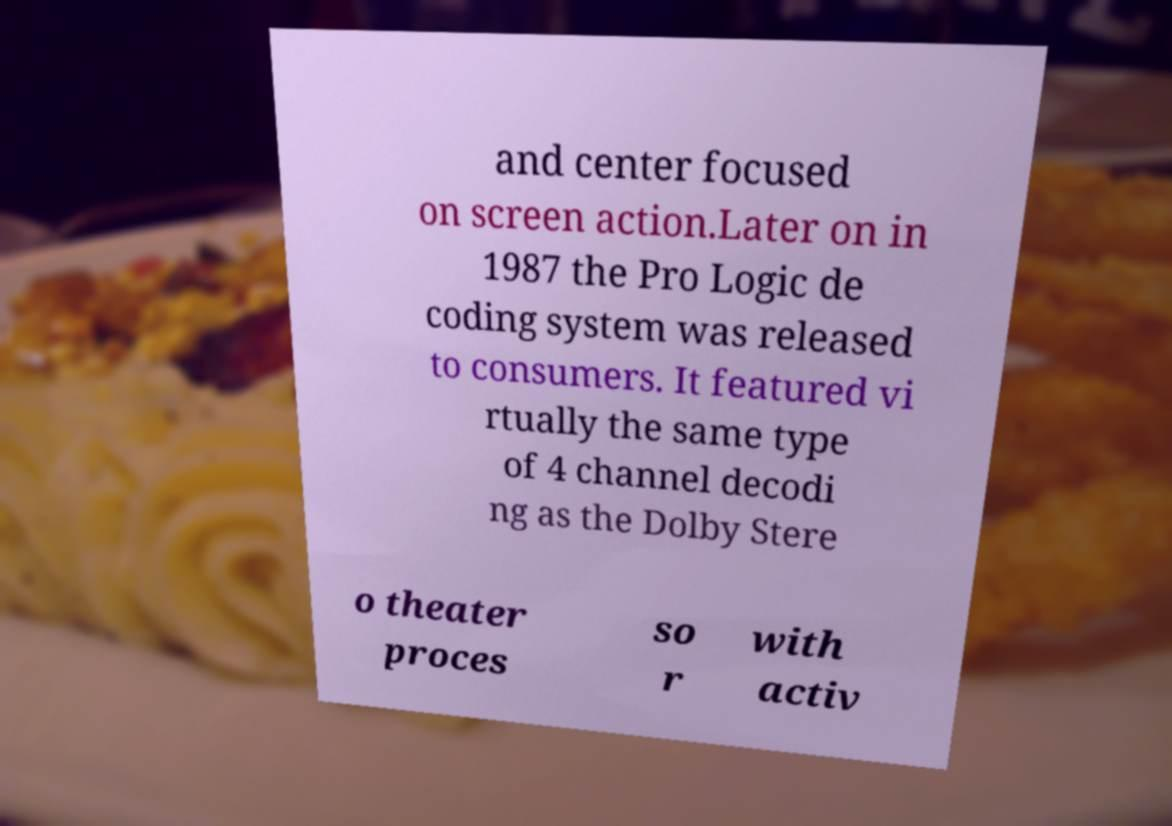Could you extract and type out the text from this image? and center focused on screen action.Later on in 1987 the Pro Logic de coding system was released to consumers. It featured vi rtually the same type of 4 channel decodi ng as the Dolby Stere o theater proces so r with activ 